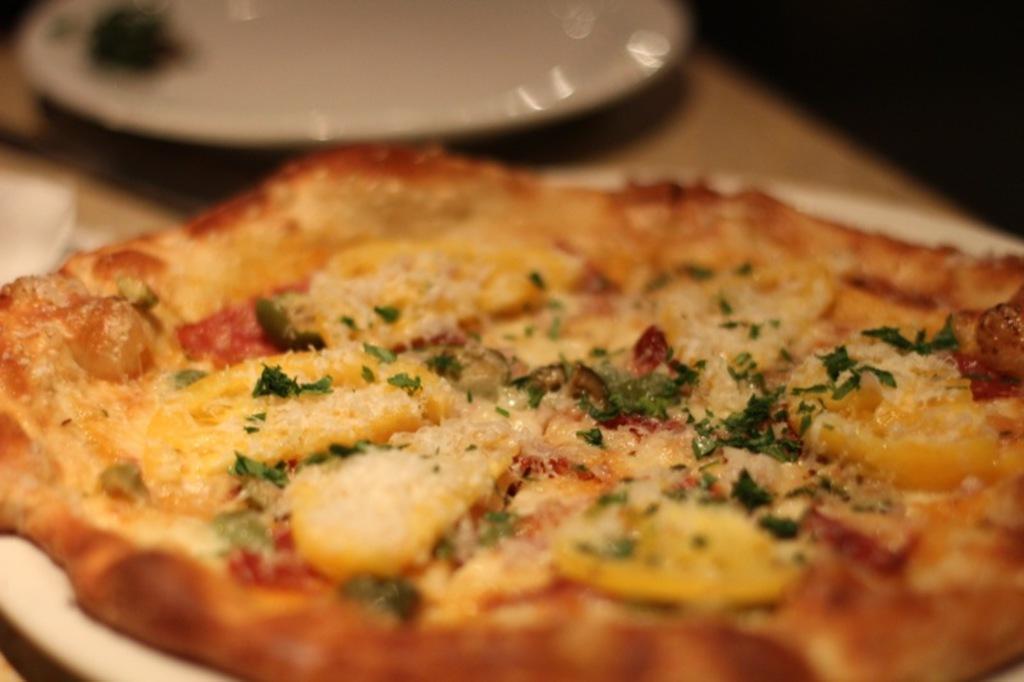How would you summarize this image in a sentence or two? In this image in front there is a pizza on the plate. Beside the pizza there is another plate on the table. 